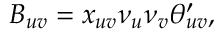Convert formula to latex. <formula><loc_0><loc_0><loc_500><loc_500>B _ { u v } = x _ { u v } \nu _ { u } \nu _ { v } \theta _ { u v } ^ { \prime } ,</formula> 